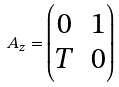Convert formula to latex. <formula><loc_0><loc_0><loc_500><loc_500>\ A _ { z } = \begin{pmatrix} 0 & 1 \\ T & 0 \end{pmatrix}</formula> 